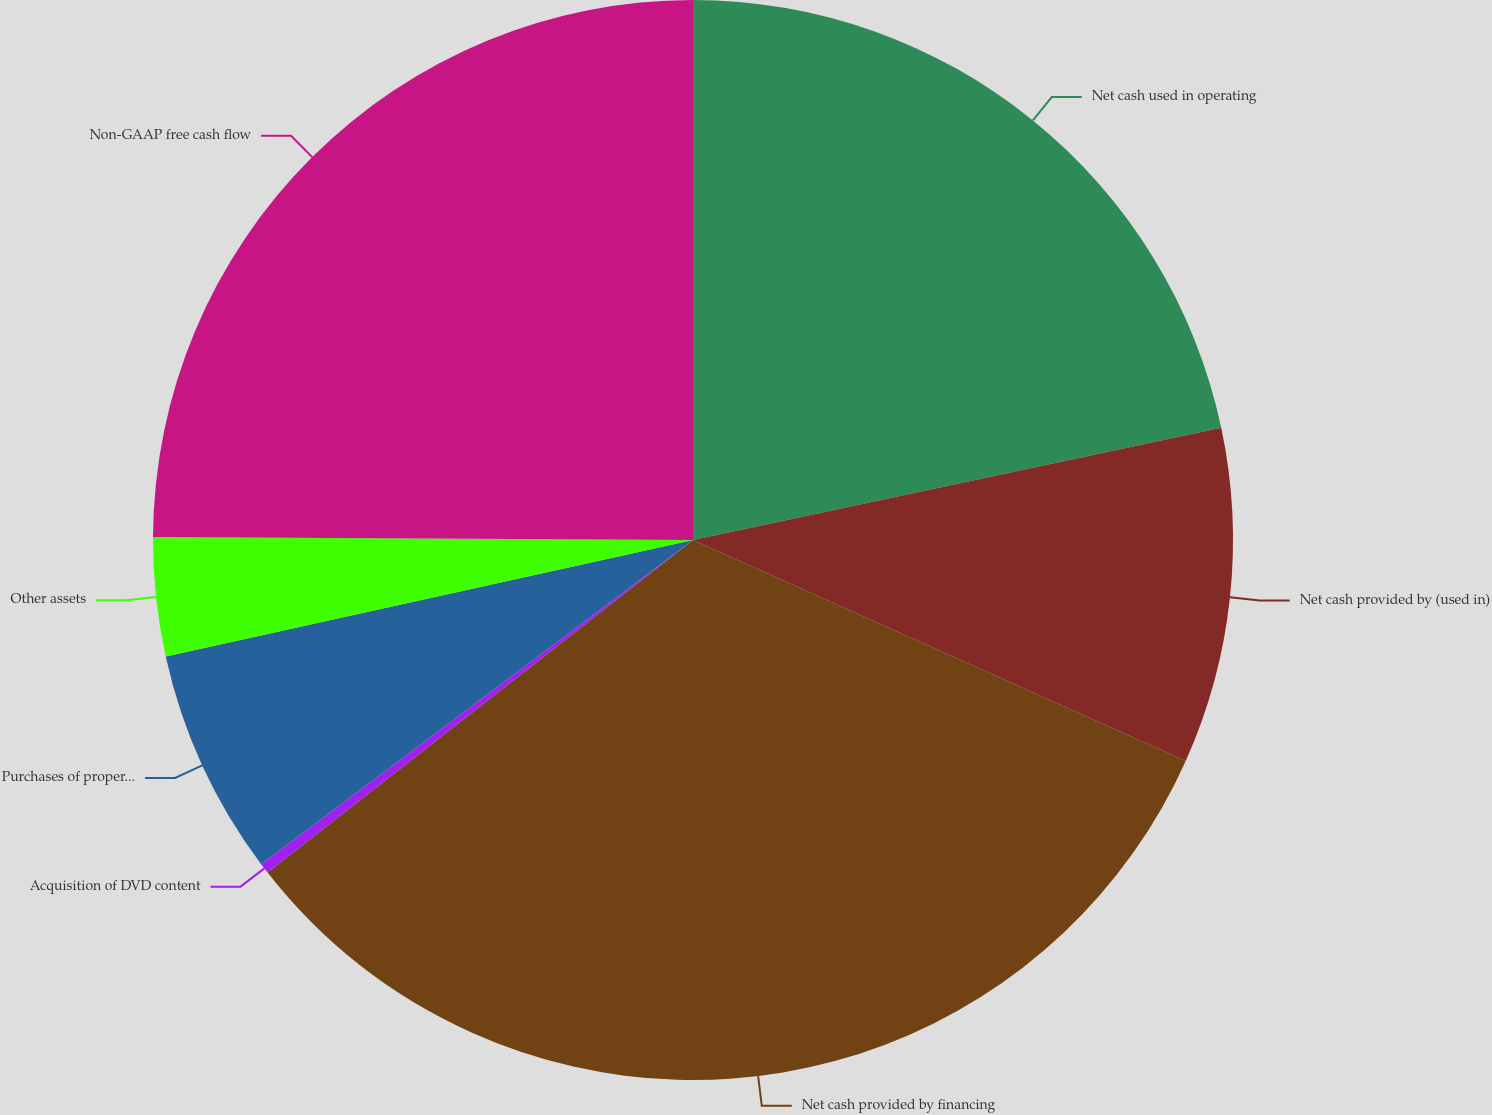Convert chart. <chart><loc_0><loc_0><loc_500><loc_500><pie_chart><fcel>Net cash used in operating<fcel>Net cash provided by (used in)<fcel>Net cash provided by financing<fcel>Acquisition of DVD content<fcel>Purchases of property and<fcel>Other assets<fcel>Non-GAAP free cash flow<nl><fcel>21.67%<fcel>10.04%<fcel>32.73%<fcel>0.31%<fcel>6.79%<fcel>3.55%<fcel>24.91%<nl></chart> 